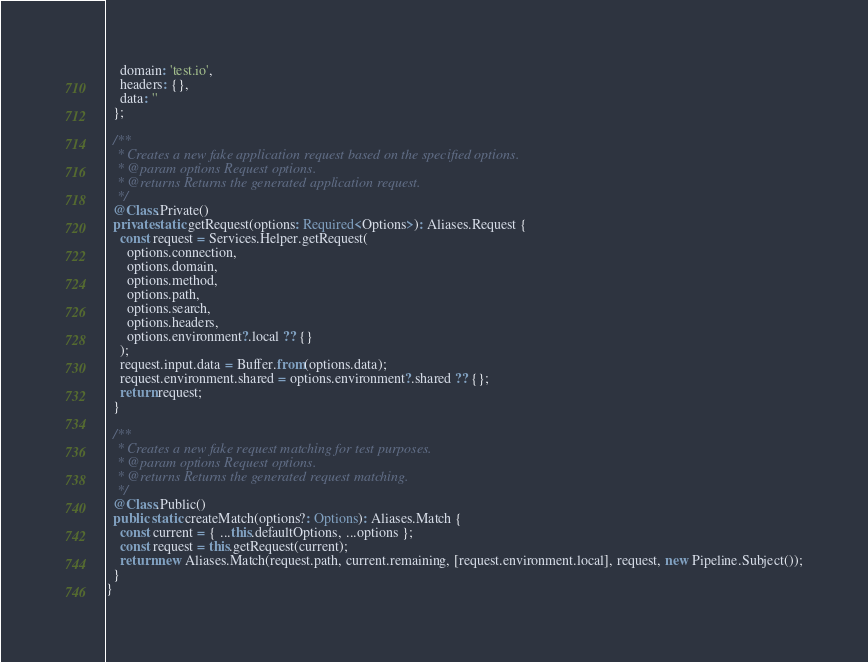Convert code to text. <code><loc_0><loc_0><loc_500><loc_500><_TypeScript_>    domain: 'test.io',
    headers: {},
    data: ''
  };

  /**
   * Creates a new fake application request based on the specified options.
   * @param options Request options.
   * @returns Returns the generated application request.
   */
  @Class.Private()
  private static getRequest(options: Required<Options>): Aliases.Request {
    const request = Services.Helper.getRequest(
      options.connection,
      options.domain,
      options.method,
      options.path,
      options.search,
      options.headers,
      options.environment?.local ?? {}
    );
    request.input.data = Buffer.from(options.data);
    request.environment.shared = options.environment?.shared ?? {};
    return request;
  }

  /**
   * Creates a new fake request matching for test purposes.
   * @param options Request options.
   * @returns Returns the generated request matching.
   */
  @Class.Public()
  public static createMatch(options?: Options): Aliases.Match {
    const current = { ...this.defaultOptions, ...options };
    const request = this.getRequest(current);
    return new Aliases.Match(request.path, current.remaining, [request.environment.local], request, new Pipeline.Subject());
  }
}
</code> 